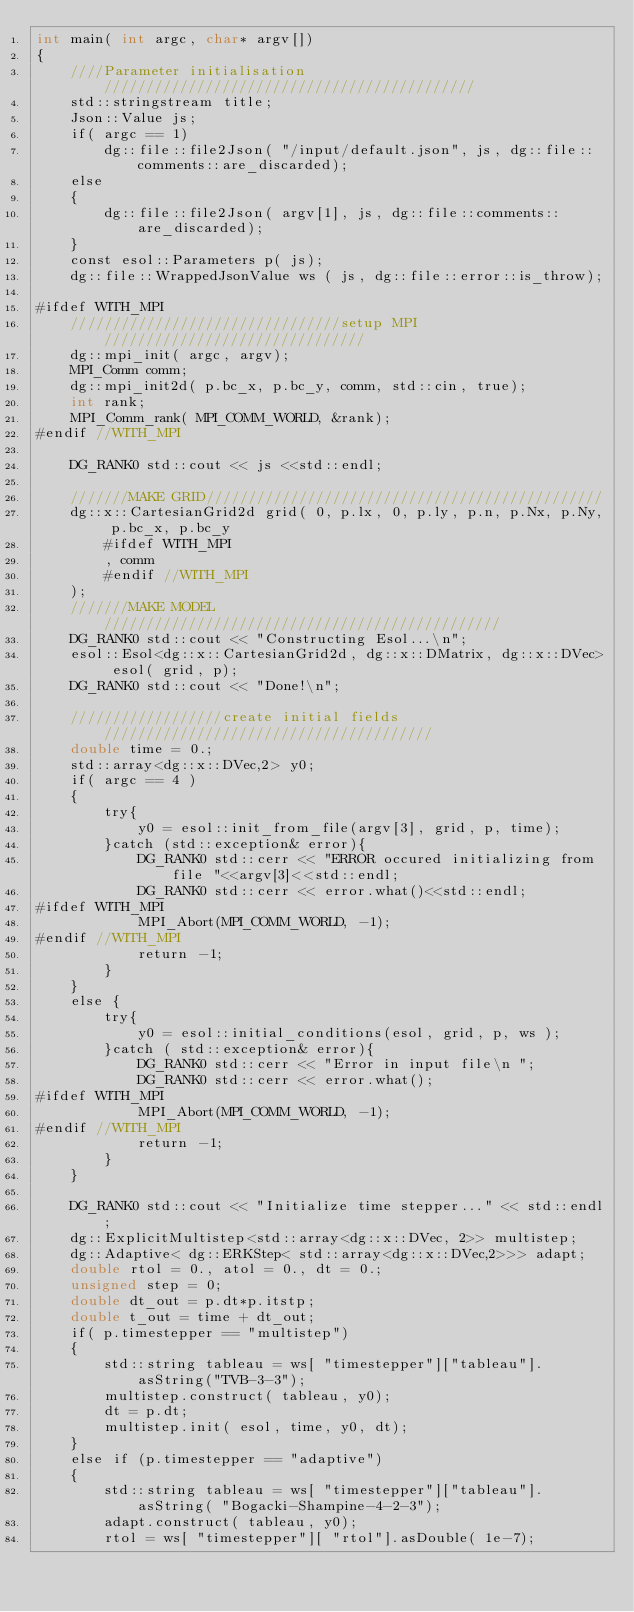<code> <loc_0><loc_0><loc_500><loc_500><_Cuda_>int main( int argc, char* argv[])
{
    ////Parameter initialisation ////////////////////////////////////////////
    std::stringstream title;
    Json::Value js;
    if( argc == 1)
        dg::file::file2Json( "/input/default.json", js, dg::file::comments::are_discarded);
    else
    {
        dg::file::file2Json( argv[1], js, dg::file::comments::are_discarded);
    }
    const esol::Parameters p( js);
    dg::file::WrappedJsonValue ws ( js, dg::file::error::is_throw);  
    
#ifdef WITH_MPI
    ////////////////////////////////setup MPI///////////////////////////////
    dg::mpi_init( argc, argv);
    MPI_Comm comm;
    dg::mpi_init2d( p.bc_x, p.bc_y, comm, std::cin, true);
    int rank;
    MPI_Comm_rank( MPI_COMM_WORLD, &rank);
#endif //WITH_MPI

    DG_RANK0 std::cout << js <<std::endl;

    ///////MAKE GRID///////////////////////////////////////////////
    dg::x::CartesianGrid2d grid( 0, p.lx, 0, p.ly, p.n, p.Nx, p.Ny, p.bc_x, p.bc_y
        #ifdef WITH_MPI
        , comm
        #endif //WITH_MPI
    );
    ///////MAKE MODEL///////////////////////////////////////////////
    DG_RANK0 std::cout << "Constructing Esol...\n";
    esol::Esol<dg::x::CartesianGrid2d, dg::x::DMatrix, dg::x::DVec> esol( grid, p);
    DG_RANK0 std::cout << "Done!\n";

    //////////////////create initial fields///////////////////////////////////////
    double time = 0.;
    std::array<dg::x::DVec,2> y0;
    if( argc == 4 )
    {
        try{
            y0 = esol::init_from_file(argv[3], grid, p, time);
        }catch (std::exception& error){
            DG_RANK0 std::cerr << "ERROR occured initializing from file "<<argv[3]<<std::endl;
            DG_RANK0 std::cerr << error.what()<<std::endl;
#ifdef WITH_MPI
            MPI_Abort(MPI_COMM_WORLD, -1);
#endif //WITH_MPI
            return -1;
        }
    }
    else {
        try{
            y0 = esol::initial_conditions(esol, grid, p, ws );
        }catch ( std::exception& error){
            DG_RANK0 std::cerr << "Error in input file\n ";
            DG_RANK0 std::cerr << error.what();
#ifdef WITH_MPI
            MPI_Abort(MPI_COMM_WORLD, -1);
#endif //WITH_MPI
            return -1;
        }
    }
    
    DG_RANK0 std::cout << "Initialize time stepper..." << std::endl;
    dg::ExplicitMultistep<std::array<dg::x::DVec, 2>> multistep;
    dg::Adaptive< dg::ERKStep< std::array<dg::x::DVec,2>>> adapt;
    double rtol = 0., atol = 0., dt = 0.;
    unsigned step = 0;
    double dt_out = p.dt*p.itstp;
    double t_out = time + dt_out;
    if( p.timestepper == "multistep")
    {
        std::string tableau = ws[ "timestepper"]["tableau"].asString("TVB-3-3");
        multistep.construct( tableau, y0);
        dt = p.dt;
        multistep.init( esol, time, y0, dt);
    }
    else if (p.timestepper == "adaptive")
    {
        std::string tableau = ws[ "timestepper"]["tableau"].asString( "Bogacki-Shampine-4-2-3");
        adapt.construct( tableau, y0);
        rtol = ws[ "timestepper"][ "rtol"].asDouble( 1e-7);</code> 